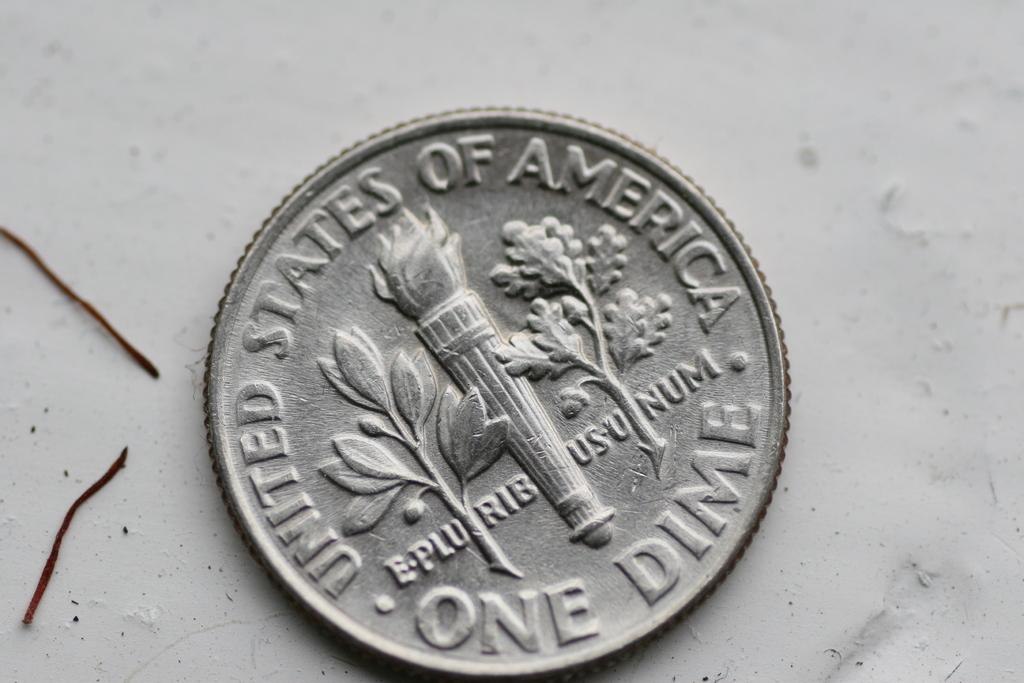<image>
Relay a brief, clear account of the picture shown. a close up of a One Dime coin on a marble surface 